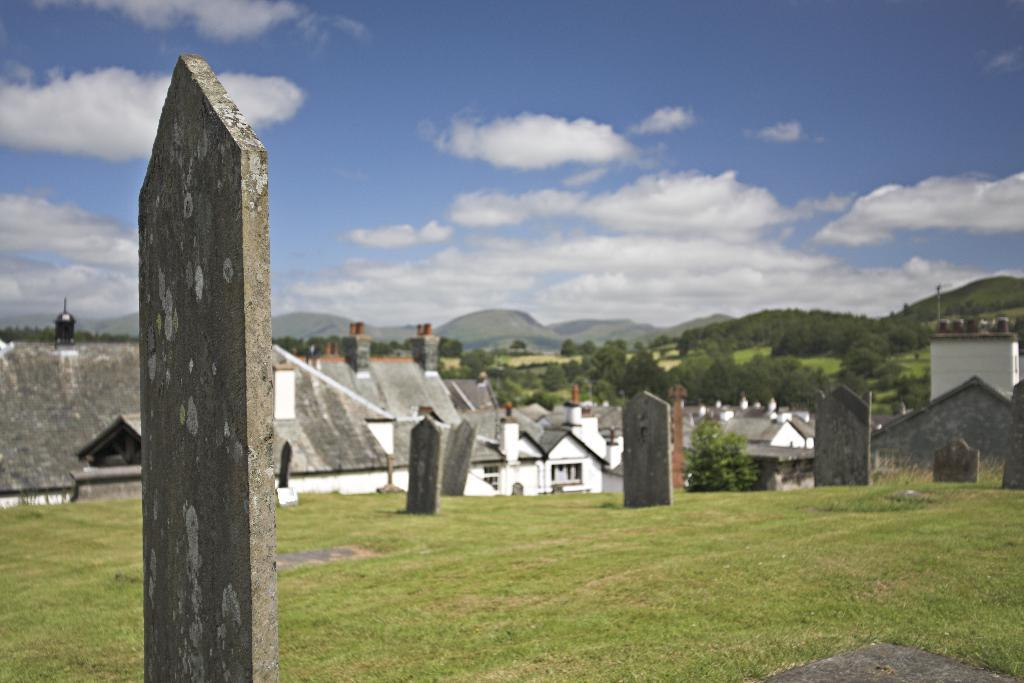What type of structures can be seen in the image? There are graveyard houses in the image. What type of vegetation is present in the image? There are trees and grass in the image. What type of terrain can be seen in the image? There are hills in the image. What is visible in the sky in the image? The sky is visible in the image, and clouds are present. How many arms are visible on the trees in the image? Trees do not have arms; they have branches. There are no visible arms on the trees in the image. 